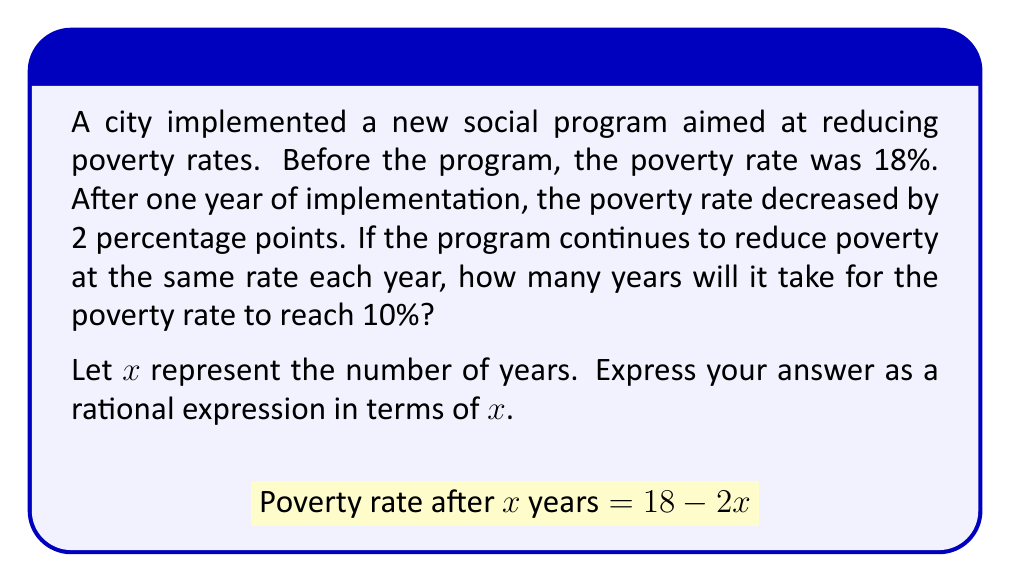What is the answer to this math problem? Let's approach this step-by-step:

1) We start with the given equation:
   $$18 - 2x = 10$$

2) Subtract 18 from both sides:
   $$-2x = -8$$

3) Divide both sides by -2:
   $$x = 4$$

4) Therefore, it will take 4 years for the poverty rate to reach 10%.

5) To express this as a rational expression in terms of $x$, we can set up the equation:
   $$\frac{18 - 10}{2} = x$$

6) Simplify:
   $$\frac{8}{2} = x$$

7) Our final rational expression is:
   $$x = \frac{4}{1}$$

This rational expression represents the number of years it will take for the poverty rate to reach 10% under the given conditions.
Answer: $x = \frac{4}{1}$ 